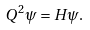Convert formula to latex. <formula><loc_0><loc_0><loc_500><loc_500>Q ^ { 2 } \psi = H \psi .</formula> 